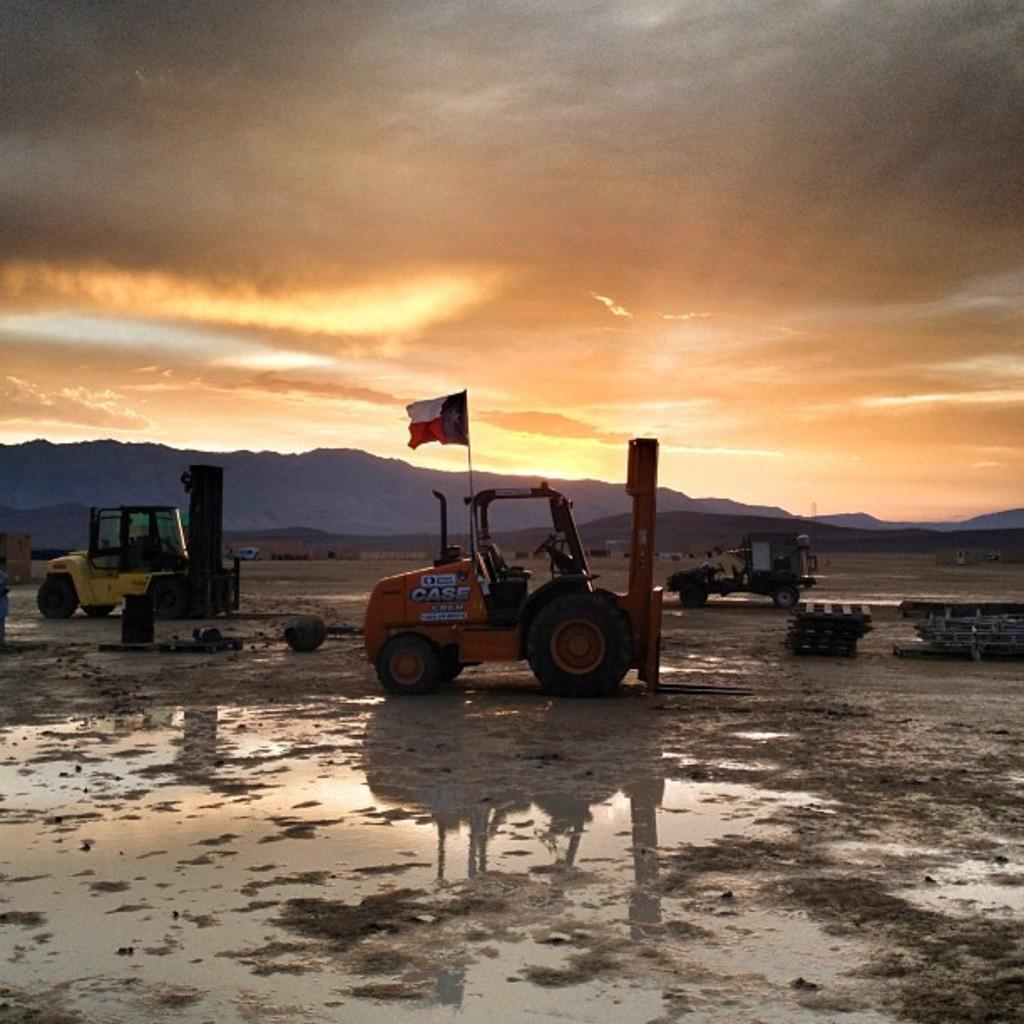What can be seen in the image related to transportation? There are vehicles in the image. Can you describe any specific detail about one of the vehicles? One of the vehicles has a flag attached. What is the condition of the ground in the image? The ground appears to be wet. What type of natural feature can be seen in the background of the image? There are mountains visible in the background. How would you describe the color of the sky in the image? The sky has an orange color. What type of frame is used to hold the porter in the image? There is no porter present in the image, and therefore no frame is needed to hold one. Can you describe the feather on the vehicle in the image? There are no feathers visible on any of the vehicles in the image. 